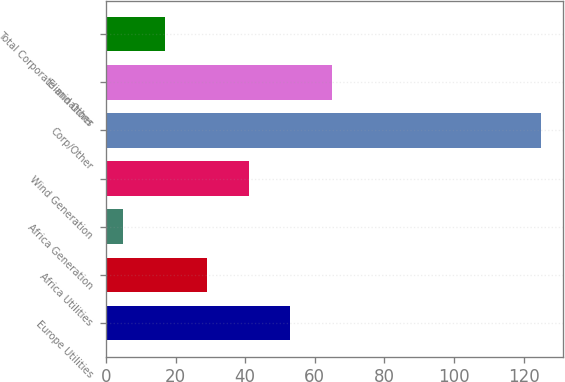Convert chart to OTSL. <chart><loc_0><loc_0><loc_500><loc_500><bar_chart><fcel>Europe Utilities<fcel>Africa Utilities<fcel>Africa Generation<fcel>Wind Generation<fcel>Corp/Other<fcel>Eliminations<fcel>Total Corporate and Other<nl><fcel>53<fcel>29<fcel>5<fcel>41<fcel>125<fcel>65<fcel>17<nl></chart> 